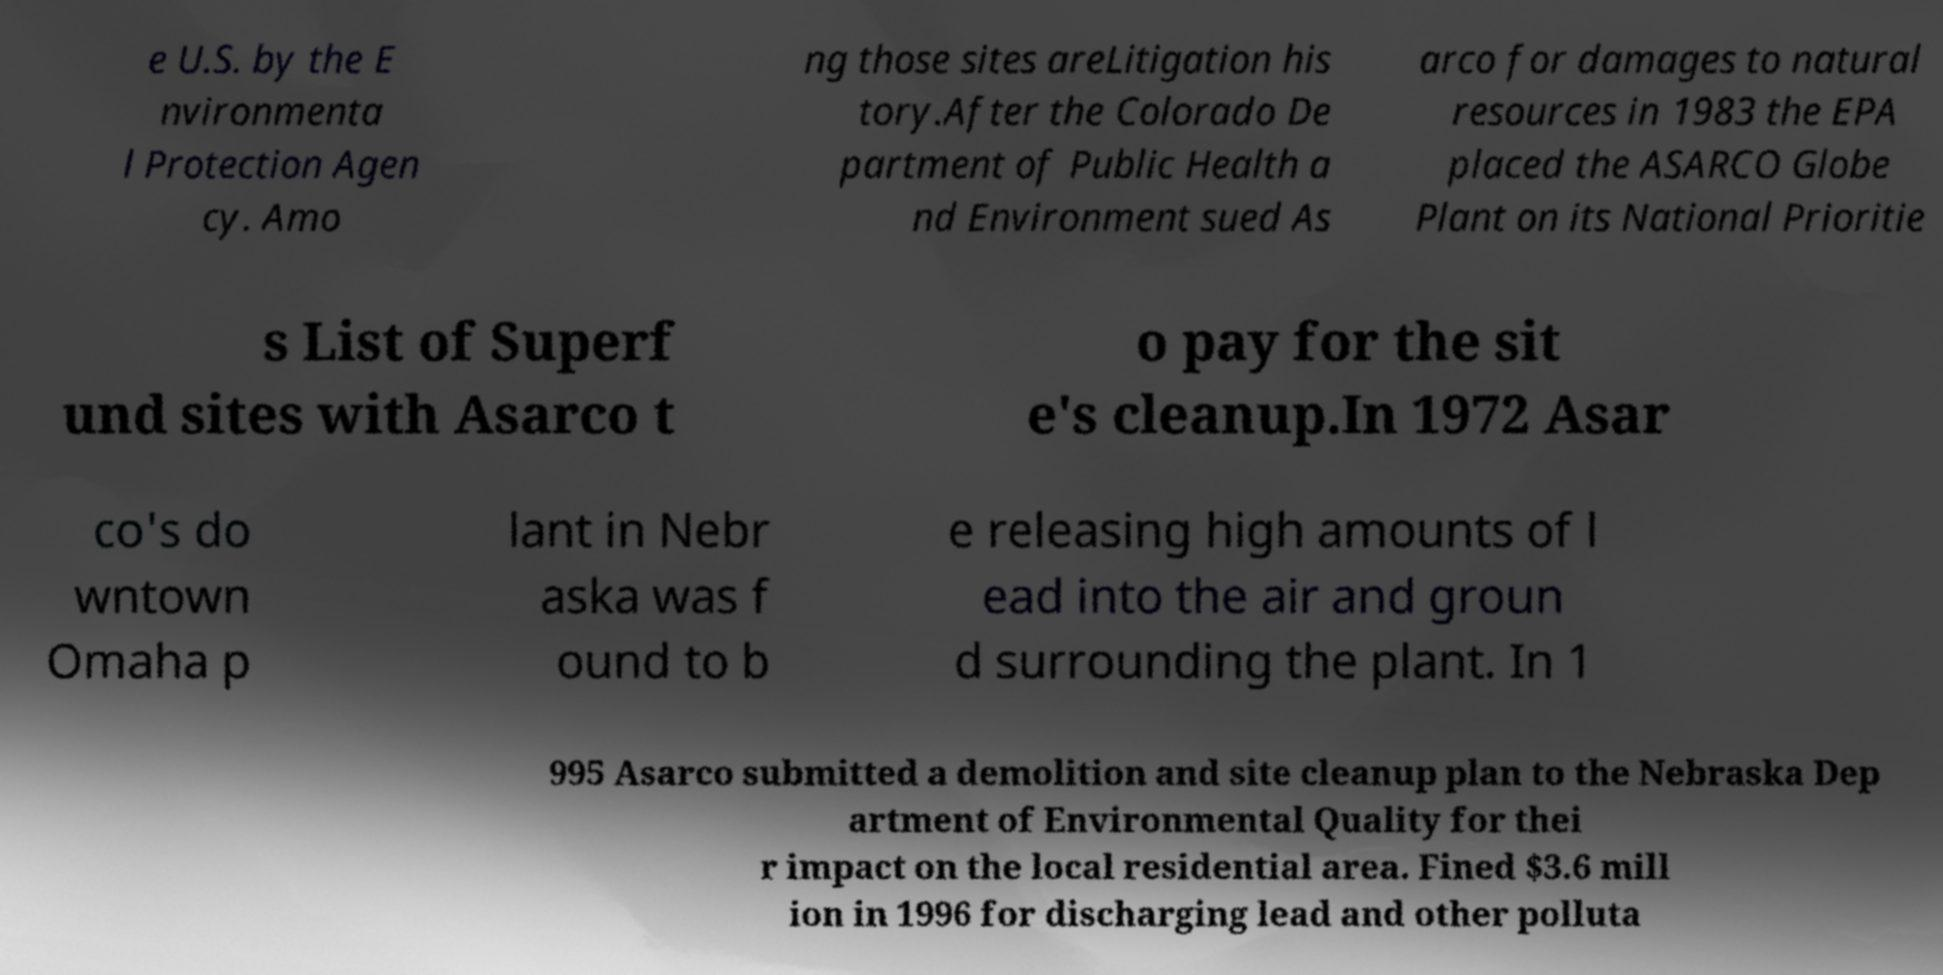For documentation purposes, I need the text within this image transcribed. Could you provide that? e U.S. by the E nvironmenta l Protection Agen cy. Amo ng those sites areLitigation his tory.After the Colorado De partment of Public Health a nd Environment sued As arco for damages to natural resources in 1983 the EPA placed the ASARCO Globe Plant on its National Prioritie s List of Superf und sites with Asarco t o pay for the sit e's cleanup.In 1972 Asar co's do wntown Omaha p lant in Nebr aska was f ound to b e releasing high amounts of l ead into the air and groun d surrounding the plant. In 1 995 Asarco submitted a demolition and site cleanup plan to the Nebraska Dep artment of Environmental Quality for thei r impact on the local residential area. Fined $3.6 mill ion in 1996 for discharging lead and other polluta 